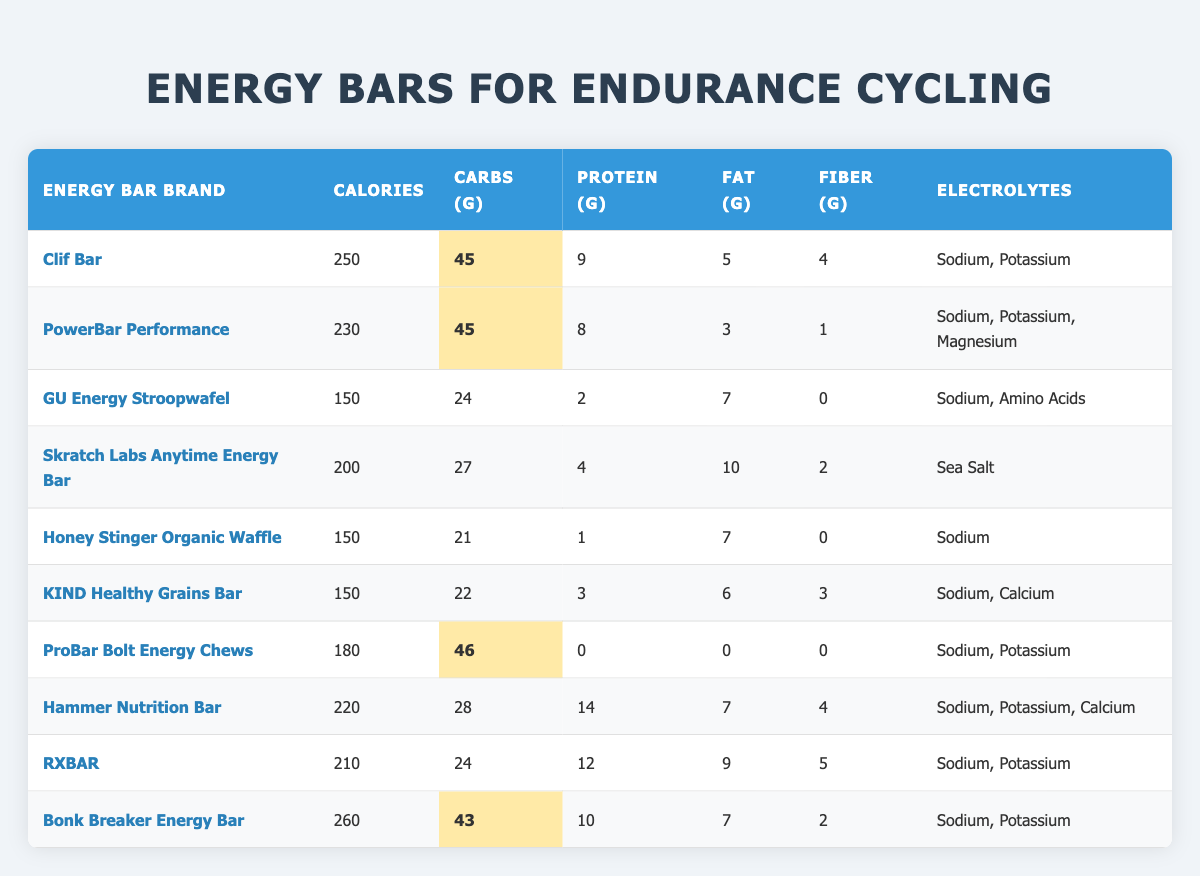What is the highest calorie count among the energy bars listed? To find the highest calorie count, I look through the "Calories" column and identify the maximum value, which is 260 for the Bonk Breaker Energy Bar.
Answer: 260 Which energy bar has the least amount of protein? By examining the "Protein (g)" column, I see that the ProBar Bolt Energy Chews have 0 grams of protein, which is the least compared to the other bars.
Answer: 0 What is the total carbohydrate content of the Clif Bar and the RXBAR combined? First, I find the carbohydrate content for each bar: Clif Bar has 45 grams and RXBAR has 24 grams. Then, I add them together: 45 + 24 = 69 grams.
Answer: 69 Does the Honey Stinger Organic Waffle contain any electrolytes? According to the "Electrolytes" column, the Honey Stinger Organic Waffle lists Sodium as the only electrolyte. Therefore, it does contain electrolytes.
Answer: Yes Which energy bar has the highest fat content, and what is that value? Looking at the "Fat (g)" column, I find that the Skratch Labs Anytime Energy Bar has the highest fat content with 10 grams.
Answer: 10 What is the average fiber content of the energy bars? To calculate the average fiber content, I sum all the fiber values: 4 + 1 + 0 + 2 + 0 + 3 + 0 + 4 + 5 + 2 = 21. Then, I divide by the number of energy bars, which is 10: 21/10 = 2.1 grams.
Answer: 2.1 Is the sodium content in all energy bars consistent? A review of the "Electrolytes" column shows that some bars have Sodium listed while others do not. Therefore, sodium content is not consistent among all energy bars.
Answer: No What is the difference in calorie count between the Bonk Breaker Energy Bar and the GU Energy Stroopwafel? The Bonk Breaker Energy Bar has 260 calories and the GU Energy Stroopwafel has 150 calories. The difference is 260 - 150 = 110 calories.
Answer: 110 